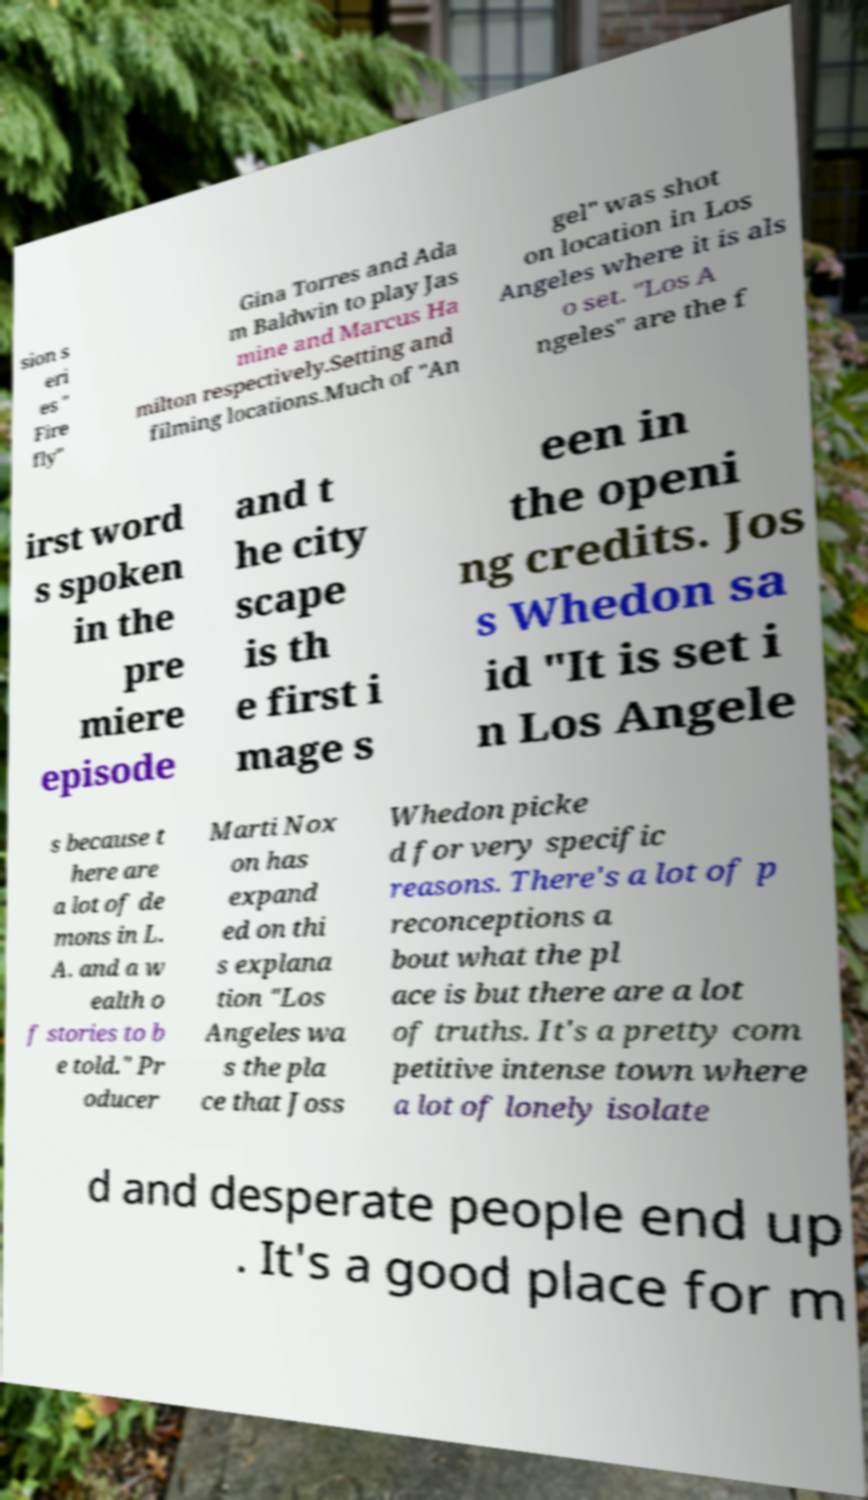Please identify and transcribe the text found in this image. sion s eri es " Fire fly" Gina Torres and Ada m Baldwin to play Jas mine and Marcus Ha milton respectively.Setting and filming locations.Much of "An gel" was shot on location in Los Angeles where it is als o set. "Los A ngeles" are the f irst word s spoken in the pre miere episode and t he city scape is th e first i mage s een in the openi ng credits. Jos s Whedon sa id "It is set i n Los Angele s because t here are a lot of de mons in L. A. and a w ealth o f stories to b e told." Pr oducer Marti Nox on has expand ed on thi s explana tion "Los Angeles wa s the pla ce that Joss Whedon picke d for very specific reasons. There's a lot of p reconceptions a bout what the pl ace is but there are a lot of truths. It's a pretty com petitive intense town where a lot of lonely isolate d and desperate people end up . It's a good place for m 